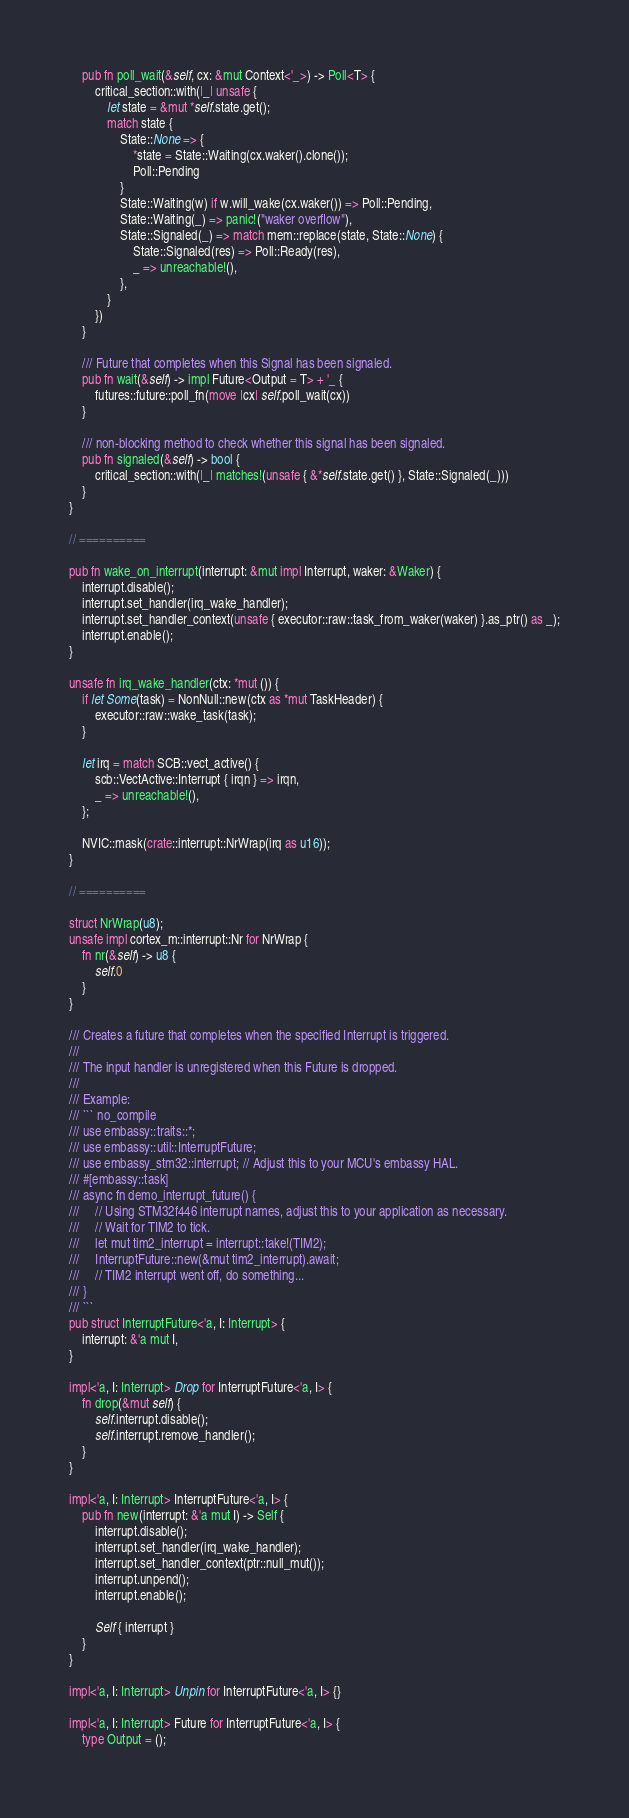Convert code to text. <code><loc_0><loc_0><loc_500><loc_500><_Rust_>
    pub fn poll_wait(&self, cx: &mut Context<'_>) -> Poll<T> {
        critical_section::with(|_| unsafe {
            let state = &mut *self.state.get();
            match state {
                State::None => {
                    *state = State::Waiting(cx.waker().clone());
                    Poll::Pending
                }
                State::Waiting(w) if w.will_wake(cx.waker()) => Poll::Pending,
                State::Waiting(_) => panic!("waker overflow"),
                State::Signaled(_) => match mem::replace(state, State::None) {
                    State::Signaled(res) => Poll::Ready(res),
                    _ => unreachable!(),
                },
            }
        })
    }

    /// Future that completes when this Signal has been signaled.
    pub fn wait(&self) -> impl Future<Output = T> + '_ {
        futures::future::poll_fn(move |cx| self.poll_wait(cx))
    }

    /// non-blocking method to check whether this signal has been signaled.
    pub fn signaled(&self) -> bool {
        critical_section::with(|_| matches!(unsafe { &*self.state.get() }, State::Signaled(_)))
    }
}

// ==========

pub fn wake_on_interrupt(interrupt: &mut impl Interrupt, waker: &Waker) {
    interrupt.disable();
    interrupt.set_handler(irq_wake_handler);
    interrupt.set_handler_context(unsafe { executor::raw::task_from_waker(waker) }.as_ptr() as _);
    interrupt.enable();
}

unsafe fn irq_wake_handler(ctx: *mut ()) {
    if let Some(task) = NonNull::new(ctx as *mut TaskHeader) {
        executor::raw::wake_task(task);
    }

    let irq = match SCB::vect_active() {
        scb::VectActive::Interrupt { irqn } => irqn,
        _ => unreachable!(),
    };

    NVIC::mask(crate::interrupt::NrWrap(irq as u16));
}

// ==========

struct NrWrap(u8);
unsafe impl cortex_m::interrupt::Nr for NrWrap {
    fn nr(&self) -> u8 {
        self.0
    }
}

/// Creates a future that completes when the specified Interrupt is triggered.
///
/// The input handler is unregistered when this Future is dropped.
///
/// Example:
/// ``` no_compile
/// use embassy::traits::*;
/// use embassy::util::InterruptFuture;
/// use embassy_stm32::interrupt; // Adjust this to your MCU's embassy HAL.
/// #[embassy::task]
/// async fn demo_interrupt_future() {
///     // Using STM32f446 interrupt names, adjust this to your application as necessary.
///     // Wait for TIM2 to tick.
///     let mut tim2_interrupt = interrupt::take!(TIM2);
///     InterruptFuture::new(&mut tim2_interrupt).await;
///     // TIM2 interrupt went off, do something...
/// }
/// ```
pub struct InterruptFuture<'a, I: Interrupt> {
    interrupt: &'a mut I,
}

impl<'a, I: Interrupt> Drop for InterruptFuture<'a, I> {
    fn drop(&mut self) {
        self.interrupt.disable();
        self.interrupt.remove_handler();
    }
}

impl<'a, I: Interrupt> InterruptFuture<'a, I> {
    pub fn new(interrupt: &'a mut I) -> Self {
        interrupt.disable();
        interrupt.set_handler(irq_wake_handler);
        interrupt.set_handler_context(ptr::null_mut());
        interrupt.unpend();
        interrupt.enable();

        Self { interrupt }
    }
}

impl<'a, I: Interrupt> Unpin for InterruptFuture<'a, I> {}

impl<'a, I: Interrupt> Future for InterruptFuture<'a, I> {
    type Output = ();
</code> 